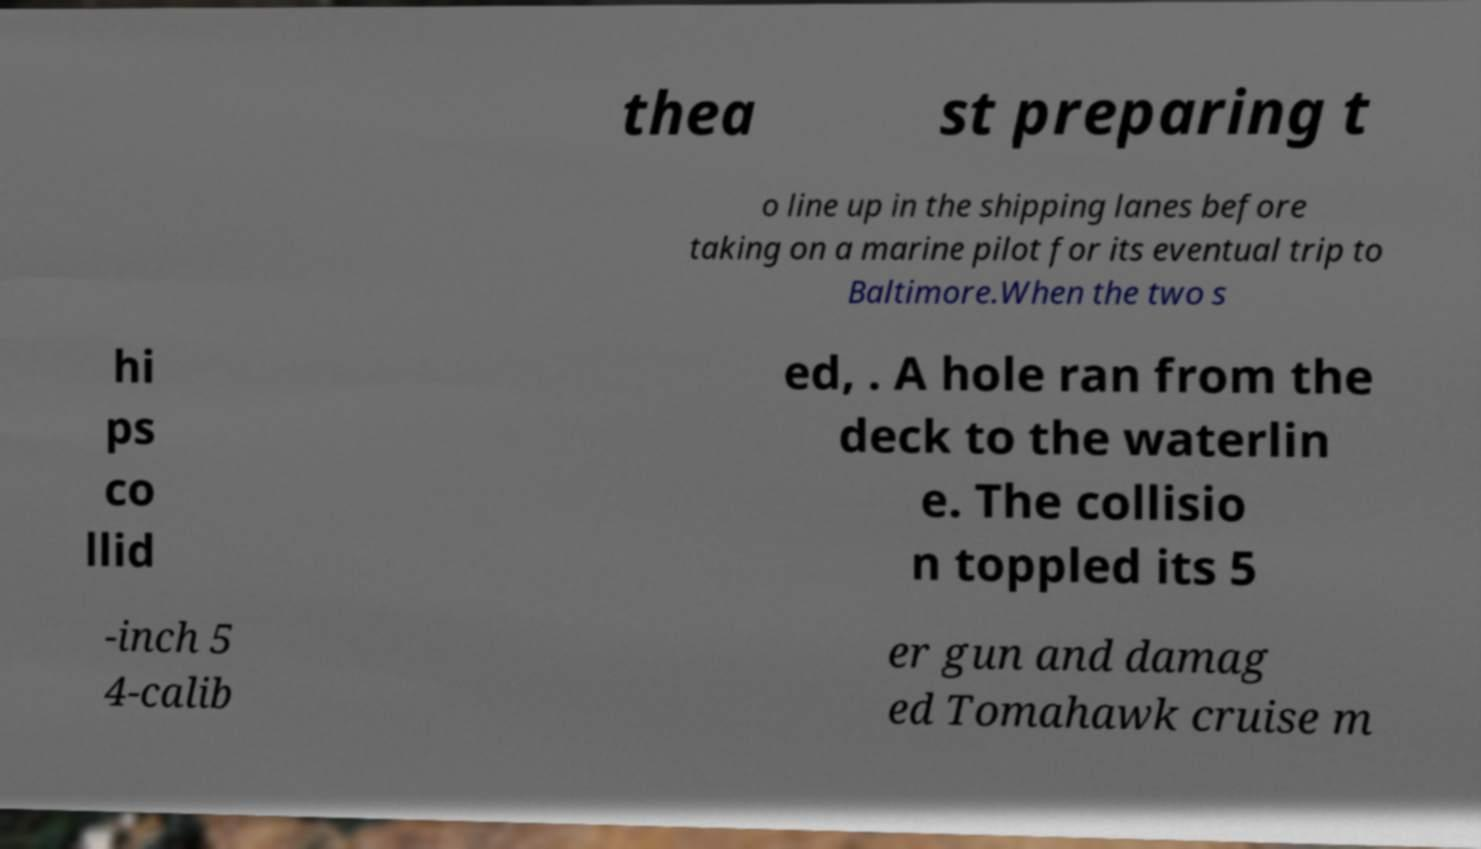For documentation purposes, I need the text within this image transcribed. Could you provide that? thea st preparing t o line up in the shipping lanes before taking on a marine pilot for its eventual trip to Baltimore.When the two s hi ps co llid ed, . A hole ran from the deck to the waterlin e. The collisio n toppled its 5 -inch 5 4-calib er gun and damag ed Tomahawk cruise m 